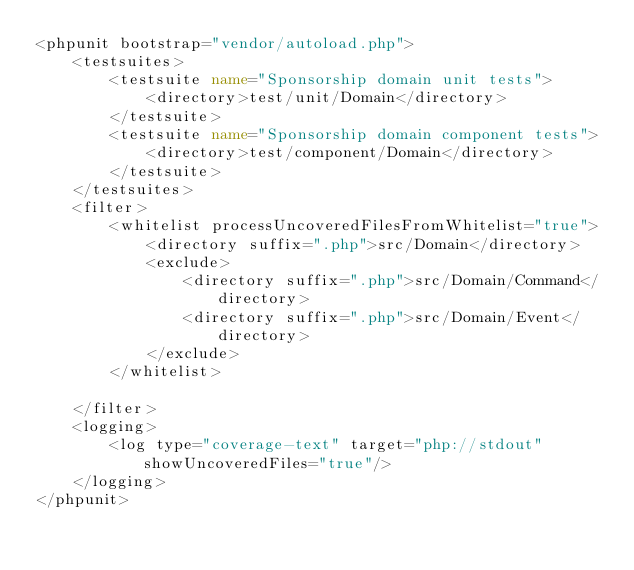<code> <loc_0><loc_0><loc_500><loc_500><_XML_><phpunit bootstrap="vendor/autoload.php">
    <testsuites>
        <testsuite name="Sponsorship domain unit tests">
            <directory>test/unit/Domain</directory>
        </testsuite>
        <testsuite name="Sponsorship domain component tests">
            <directory>test/component/Domain</directory>
        </testsuite>
    </testsuites>
    <filter>
        <whitelist processUncoveredFilesFromWhitelist="true">
            <directory suffix=".php">src/Domain</directory>
            <exclude>
                <directory suffix=".php">src/Domain/Command</directory>
                <directory suffix=".php">src/Domain/Event</directory>
            </exclude>
        </whitelist>

    </filter>
    <logging>
        <log type="coverage-text" target="php://stdout" showUncoveredFiles="true"/>
    </logging>
</phpunit></code> 